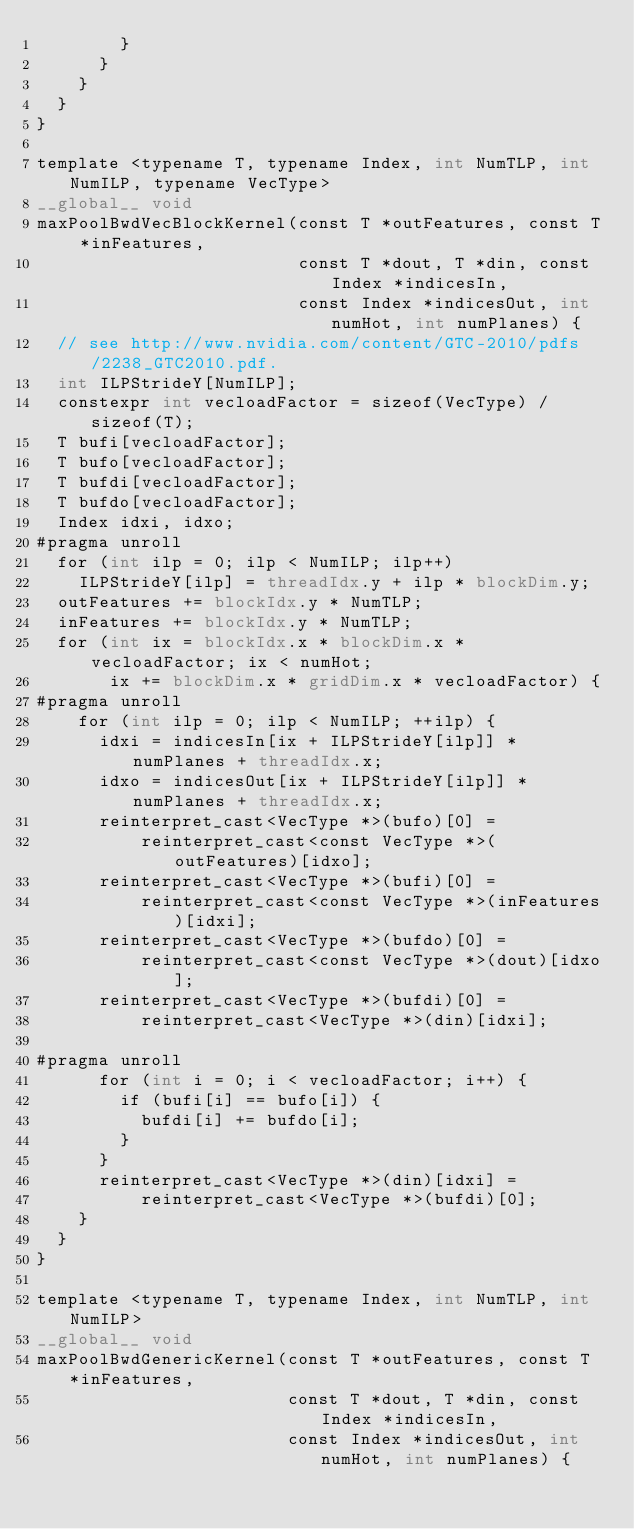Convert code to text. <code><loc_0><loc_0><loc_500><loc_500><_Cuda_>        }
      }
    }
  }
}

template <typename T, typename Index, int NumTLP, int NumILP, typename VecType>
__global__ void
maxPoolBwdVecBlockKernel(const T *outFeatures, const T *inFeatures,
                         const T *dout, T *din, const Index *indicesIn,
                         const Index *indicesOut, int numHot, int numPlanes) {
  // see http://www.nvidia.com/content/GTC-2010/pdfs/2238_GTC2010.pdf.
  int ILPStrideY[NumILP];
  constexpr int vecloadFactor = sizeof(VecType) / sizeof(T);
  T bufi[vecloadFactor];
  T bufo[vecloadFactor];
  T bufdi[vecloadFactor];
  T bufdo[vecloadFactor];
  Index idxi, idxo;
#pragma unroll
  for (int ilp = 0; ilp < NumILP; ilp++)
    ILPStrideY[ilp] = threadIdx.y + ilp * blockDim.y;
  outFeatures += blockIdx.y * NumTLP;
  inFeatures += blockIdx.y * NumTLP;
  for (int ix = blockIdx.x * blockDim.x * vecloadFactor; ix < numHot;
       ix += blockDim.x * gridDim.x * vecloadFactor) {
#pragma unroll
    for (int ilp = 0; ilp < NumILP; ++ilp) {
      idxi = indicesIn[ix + ILPStrideY[ilp]] * numPlanes + threadIdx.x;
      idxo = indicesOut[ix + ILPStrideY[ilp]] * numPlanes + threadIdx.x;
      reinterpret_cast<VecType *>(bufo)[0] =
          reinterpret_cast<const VecType *>(outFeatures)[idxo];
      reinterpret_cast<VecType *>(bufi)[0] =
          reinterpret_cast<const VecType *>(inFeatures)[idxi];
      reinterpret_cast<VecType *>(bufdo)[0] =
          reinterpret_cast<const VecType *>(dout)[idxo];
      reinterpret_cast<VecType *>(bufdi)[0] =
          reinterpret_cast<VecType *>(din)[idxi];

#pragma unroll
      for (int i = 0; i < vecloadFactor; i++) {
        if (bufi[i] == bufo[i]) {
          bufdi[i] += bufdo[i];
        }
      }
      reinterpret_cast<VecType *>(din)[idxi] =
          reinterpret_cast<VecType *>(bufdi)[0];
    }
  }
}

template <typename T, typename Index, int NumTLP, int NumILP>
__global__ void
maxPoolBwdGenericKernel(const T *outFeatures, const T *inFeatures,
                        const T *dout, T *din, const Index *indicesIn,
                        const Index *indicesOut, int numHot, int numPlanes) {</code> 